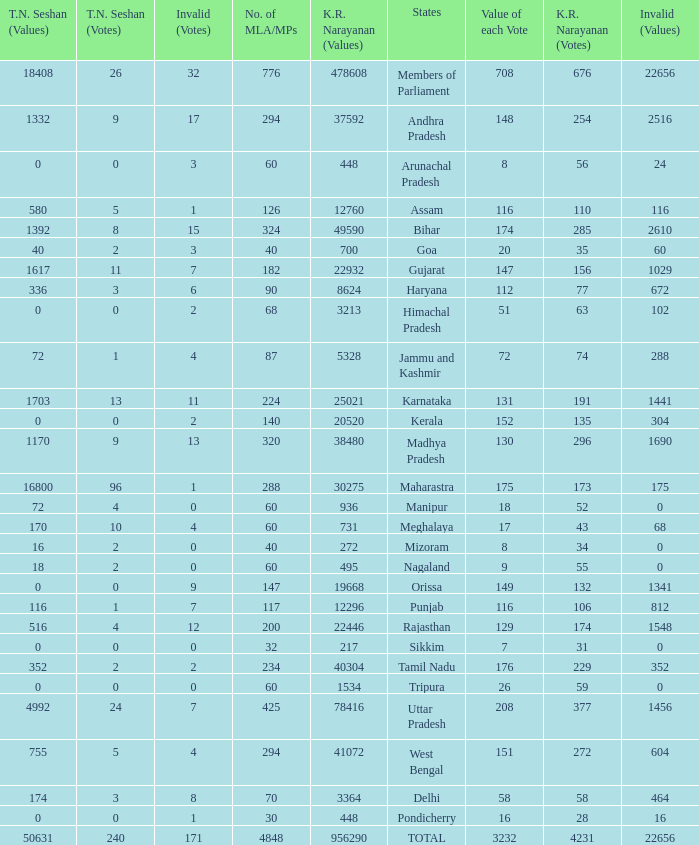Name the number of tn seshan values for kr values is 478608 1.0. 